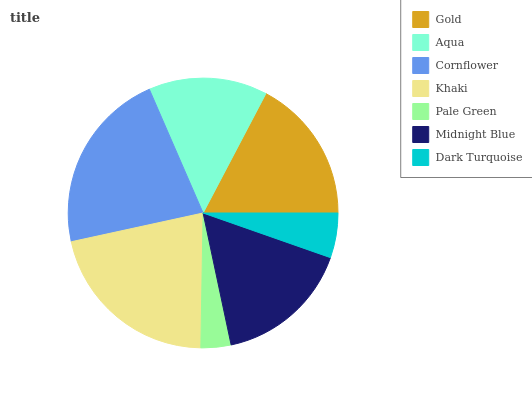Is Pale Green the minimum?
Answer yes or no. Yes. Is Cornflower the maximum?
Answer yes or no. Yes. Is Aqua the minimum?
Answer yes or no. No. Is Aqua the maximum?
Answer yes or no. No. Is Gold greater than Aqua?
Answer yes or no. Yes. Is Aqua less than Gold?
Answer yes or no. Yes. Is Aqua greater than Gold?
Answer yes or no. No. Is Gold less than Aqua?
Answer yes or no. No. Is Midnight Blue the high median?
Answer yes or no. Yes. Is Midnight Blue the low median?
Answer yes or no. Yes. Is Gold the high median?
Answer yes or no. No. Is Aqua the low median?
Answer yes or no. No. 